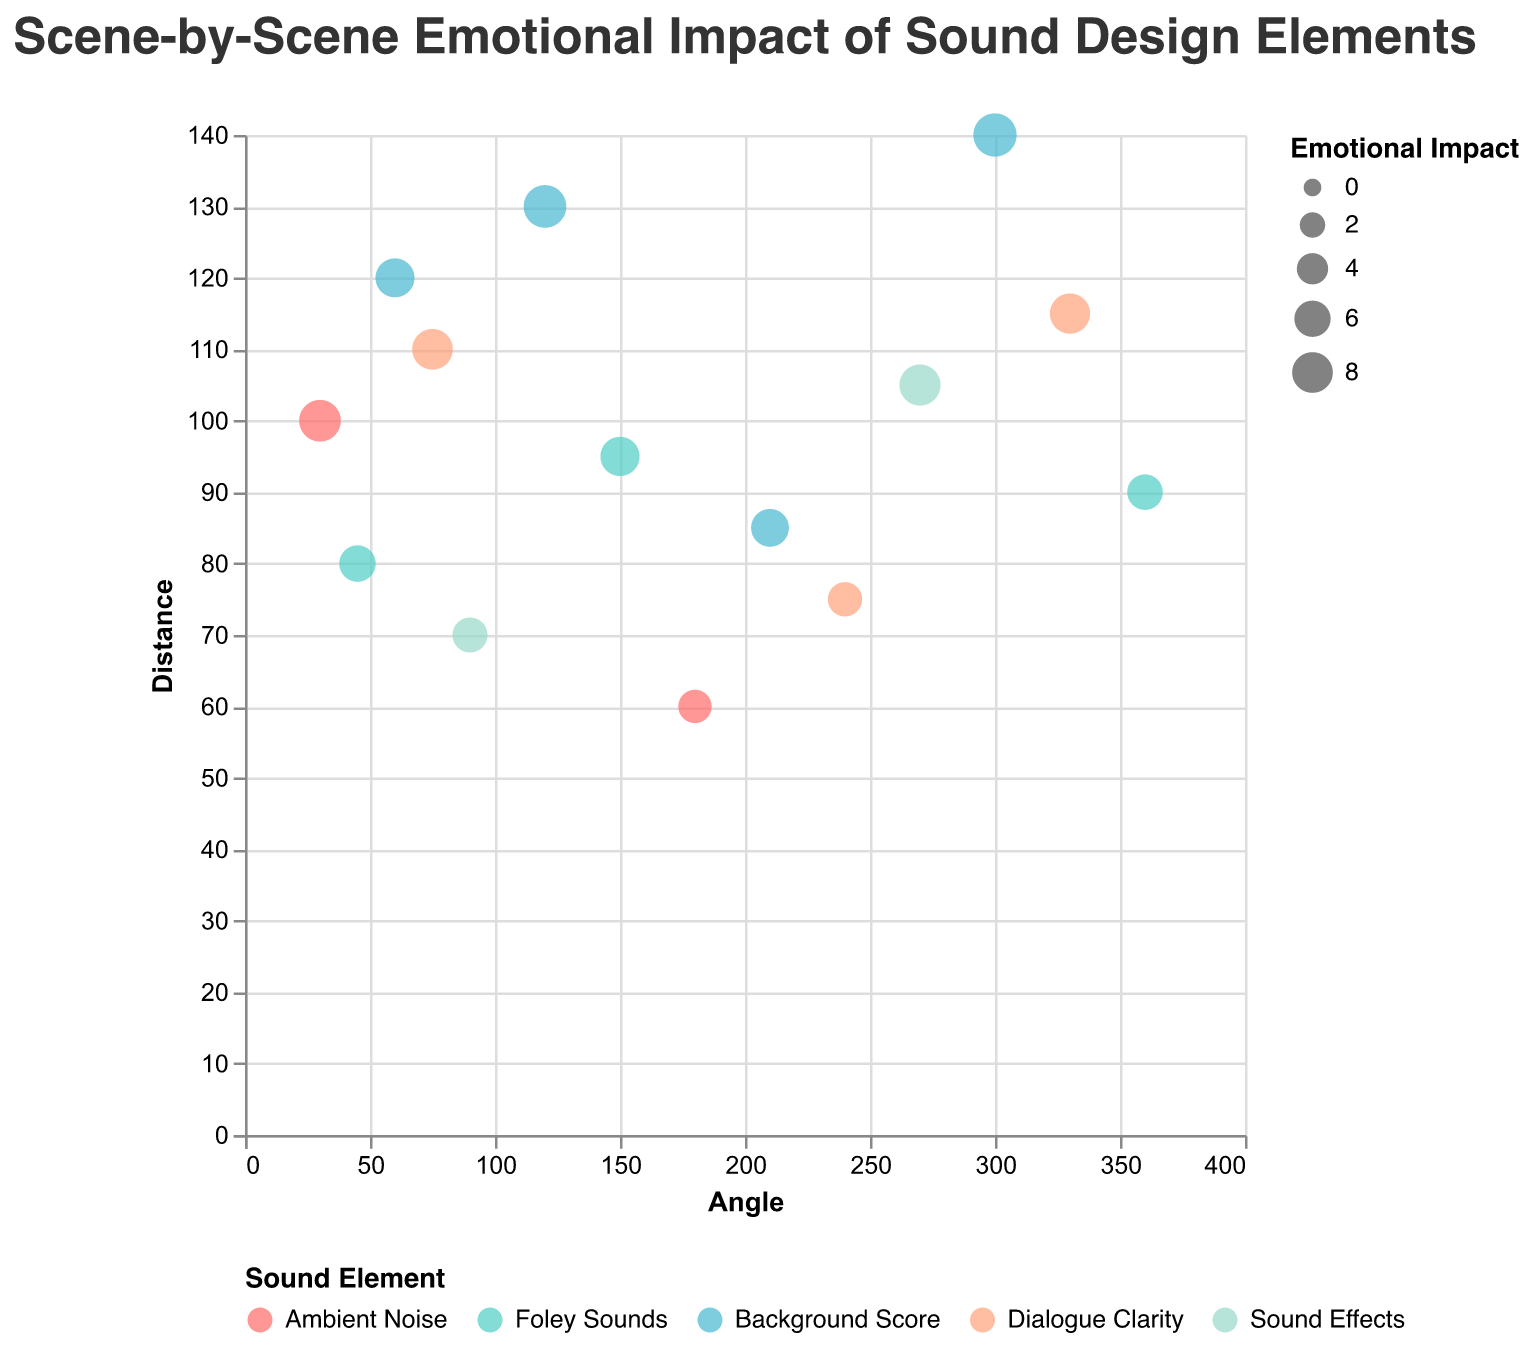What's the title of the plot? The title is located prominently at the top of the plot, indicating the main topic and focus.
Answer: Scene-by-Scene Emotional Impact of Sound Design Elements How many sound elements are represented in the plot? The legend at the bottom shows distinct colors for each sound element. Counting these colors gives us the number of sound elements.
Answer: 5 Which sound element has the highest emotional impact? By examining the size of the points, the largest one corresponds to the highest emotional impact. The tooltip or largest point will indicate the sound element.
Answer: Background Score with 9.3 Which point represents the greatest distance? The outermost point from the center has the greatest distance. Checking the tooltip or position furthest out will show the sound element and distance.
Answer: Background Score at 140 What is the average emotional impact rating for Foley Sounds? Identify all points labeled as "Foley Sounds" and calculate their average emotional impact. The points are (6.1, 7.3, 5.7). Sum (6.1 + 7.3 + 5.7) = 19.1, then divide by 3.
Answer: 6.37 Is Dialogue Clarity more or less impactful on average compared to Sound Effects? Find the average emotional impact for both sound elements. Dialogue Clarity points (8.0, 5.2, 7.8) average to 7.0. Sound Effects points (5.5, 8.2) average to 6.85. Compare these averages.
Answer: More impactful Which sound element has the least overall distance on average? Calculate the average distance for each sound element individually. Find the one with the smallest average by adding distances and dividing by number of points for each element. Foley Sounds' distances: (80, 95, 90) = 265, divided by 3 is 88.3. The rest: Ambient Noise (100, 60), Background Score (120, 130, 85, 140), Dialogue Clarity (110, 75, 115), Sound Effects (70, 105) Average. Foley Sounds have the least.
Answer: Foley Sounds How does the average distance for Background Score compare to the overall average distance? Calculate Background Score distances' average, then calculate overall distances' average and compare. Background Score (120, 130, 85, 140) sums to 475, divided by 4 is 118.75. Sum all distances (100, 80, 120, 110, 70, 130, 95, 60, 85, 75, 105, 140, 115, 90 = 1375, divided by 14 is 98.21. Compare both.
Answer: Higher What's the range of emotional impact for Sound Effects? Identify the lowest and highest emotional impact values for Sound Effects and subtract the smallest from the largest. Points (5.5, 8.2). Range is 8.2 - 5.5.
Answer: 2.7 Which angle has the highest concentration of sound elements? Observe angular positions and determine which angle has the most data points. Count data points around various angles like the usual suspect ones. For instance, no repeated exact angles, and any singular concentration will be noted.
Answer: No specific concentration 